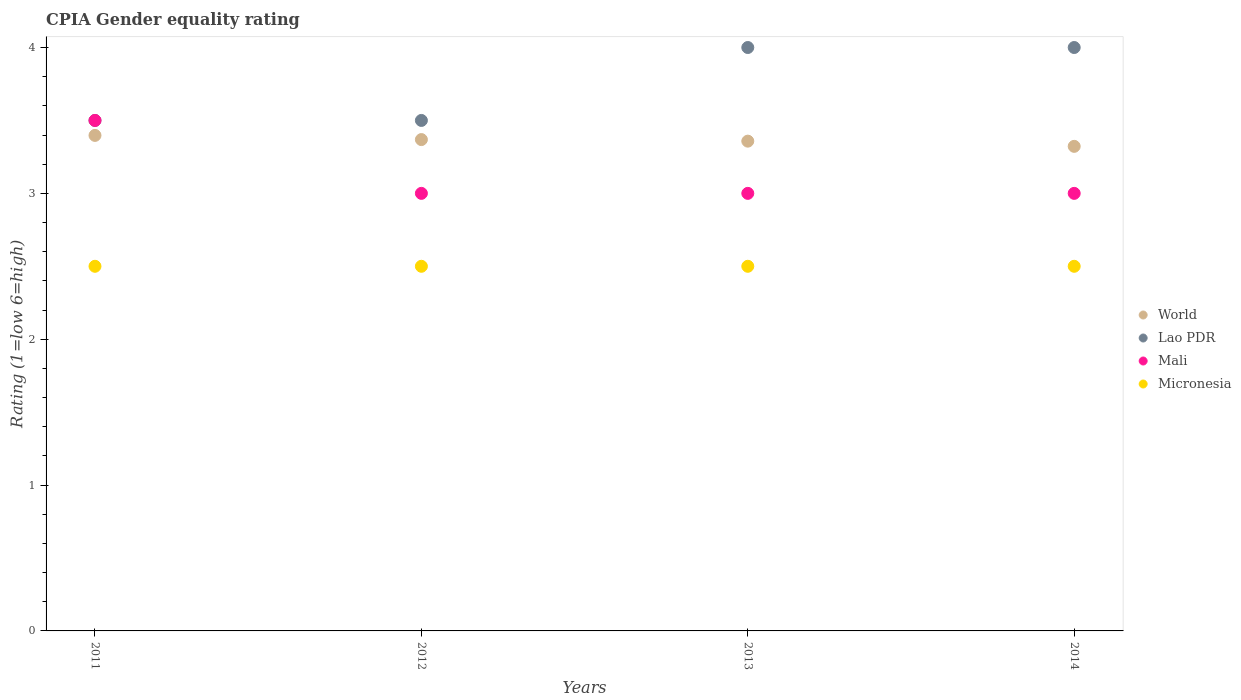How many different coloured dotlines are there?
Your answer should be compact. 4. What is the CPIA rating in World in 2011?
Your answer should be compact. 3.4. Across all years, what is the maximum CPIA rating in Lao PDR?
Your response must be concise. 4. Across all years, what is the minimum CPIA rating in Micronesia?
Ensure brevity in your answer.  2.5. In which year was the CPIA rating in Micronesia maximum?
Your answer should be compact. 2011. What is the total CPIA rating in Lao PDR in the graph?
Your answer should be very brief. 15. What is the average CPIA rating in World per year?
Provide a short and direct response. 3.36. In how many years, is the CPIA rating in Mali greater than 1.6?
Keep it short and to the point. 4. Is the difference between the CPIA rating in Micronesia in 2011 and 2012 greater than the difference between the CPIA rating in Lao PDR in 2011 and 2012?
Provide a short and direct response. No. What is the difference between the highest and the second highest CPIA rating in World?
Ensure brevity in your answer.  0.03. What is the difference between the highest and the lowest CPIA rating in Mali?
Keep it short and to the point. 0.5. Is the sum of the CPIA rating in Mali in 2013 and 2014 greater than the maximum CPIA rating in Lao PDR across all years?
Your answer should be very brief. Yes. Is it the case that in every year, the sum of the CPIA rating in Lao PDR and CPIA rating in World  is greater than the sum of CPIA rating in Micronesia and CPIA rating in Mali?
Provide a succinct answer. No. How many dotlines are there?
Your response must be concise. 4. Does the graph contain any zero values?
Provide a short and direct response. No. Where does the legend appear in the graph?
Your response must be concise. Center right. How many legend labels are there?
Your response must be concise. 4. How are the legend labels stacked?
Keep it short and to the point. Vertical. What is the title of the graph?
Provide a short and direct response. CPIA Gender equality rating. Does "Andorra" appear as one of the legend labels in the graph?
Your answer should be very brief. No. What is the label or title of the X-axis?
Provide a short and direct response. Years. What is the label or title of the Y-axis?
Give a very brief answer. Rating (1=low 6=high). What is the Rating (1=low 6=high) of World in 2011?
Your answer should be very brief. 3.4. What is the Rating (1=low 6=high) of Mali in 2011?
Make the answer very short. 3.5. What is the Rating (1=low 6=high) in Micronesia in 2011?
Your response must be concise. 2.5. What is the Rating (1=low 6=high) in World in 2012?
Keep it short and to the point. 3.37. What is the Rating (1=low 6=high) in Mali in 2012?
Your answer should be very brief. 3. What is the Rating (1=low 6=high) of Micronesia in 2012?
Ensure brevity in your answer.  2.5. What is the Rating (1=low 6=high) of World in 2013?
Offer a terse response. 3.36. What is the Rating (1=low 6=high) of Mali in 2013?
Your answer should be compact. 3. What is the Rating (1=low 6=high) of World in 2014?
Ensure brevity in your answer.  3.32. What is the Rating (1=low 6=high) of Lao PDR in 2014?
Offer a very short reply. 4. Across all years, what is the maximum Rating (1=low 6=high) of World?
Your response must be concise. 3.4. Across all years, what is the maximum Rating (1=low 6=high) of Mali?
Provide a succinct answer. 3.5. Across all years, what is the maximum Rating (1=low 6=high) of Micronesia?
Make the answer very short. 2.5. Across all years, what is the minimum Rating (1=low 6=high) in World?
Provide a succinct answer. 3.32. Across all years, what is the minimum Rating (1=low 6=high) in Lao PDR?
Ensure brevity in your answer.  3.5. Across all years, what is the minimum Rating (1=low 6=high) of Mali?
Your response must be concise. 3. Across all years, what is the minimum Rating (1=low 6=high) in Micronesia?
Your answer should be very brief. 2.5. What is the total Rating (1=low 6=high) of World in the graph?
Give a very brief answer. 13.45. What is the difference between the Rating (1=low 6=high) in World in 2011 and that in 2012?
Provide a succinct answer. 0.03. What is the difference between the Rating (1=low 6=high) of Lao PDR in 2011 and that in 2012?
Provide a short and direct response. 0. What is the difference between the Rating (1=low 6=high) of Mali in 2011 and that in 2012?
Make the answer very short. 0.5. What is the difference between the Rating (1=low 6=high) of Micronesia in 2011 and that in 2012?
Your answer should be very brief. 0. What is the difference between the Rating (1=low 6=high) in World in 2011 and that in 2013?
Keep it short and to the point. 0.04. What is the difference between the Rating (1=low 6=high) in Mali in 2011 and that in 2013?
Provide a short and direct response. 0.5. What is the difference between the Rating (1=low 6=high) in Micronesia in 2011 and that in 2013?
Provide a succinct answer. 0. What is the difference between the Rating (1=low 6=high) of World in 2011 and that in 2014?
Your response must be concise. 0.08. What is the difference between the Rating (1=low 6=high) of Mali in 2011 and that in 2014?
Offer a terse response. 0.5. What is the difference between the Rating (1=low 6=high) in World in 2012 and that in 2013?
Make the answer very short. 0.01. What is the difference between the Rating (1=low 6=high) of Lao PDR in 2012 and that in 2013?
Make the answer very short. -0.5. What is the difference between the Rating (1=low 6=high) in World in 2012 and that in 2014?
Offer a terse response. 0.05. What is the difference between the Rating (1=low 6=high) of Micronesia in 2012 and that in 2014?
Give a very brief answer. 0. What is the difference between the Rating (1=low 6=high) of World in 2013 and that in 2014?
Ensure brevity in your answer.  0.04. What is the difference between the Rating (1=low 6=high) in Lao PDR in 2013 and that in 2014?
Make the answer very short. 0. What is the difference between the Rating (1=low 6=high) of Micronesia in 2013 and that in 2014?
Make the answer very short. 0. What is the difference between the Rating (1=low 6=high) of World in 2011 and the Rating (1=low 6=high) of Lao PDR in 2012?
Keep it short and to the point. -0.1. What is the difference between the Rating (1=low 6=high) in World in 2011 and the Rating (1=low 6=high) in Mali in 2012?
Your answer should be compact. 0.4. What is the difference between the Rating (1=low 6=high) of World in 2011 and the Rating (1=low 6=high) of Micronesia in 2012?
Your answer should be very brief. 0.9. What is the difference between the Rating (1=low 6=high) in Lao PDR in 2011 and the Rating (1=low 6=high) in Mali in 2012?
Your answer should be very brief. 0.5. What is the difference between the Rating (1=low 6=high) in Lao PDR in 2011 and the Rating (1=low 6=high) in Micronesia in 2012?
Your answer should be very brief. 1. What is the difference between the Rating (1=low 6=high) of World in 2011 and the Rating (1=low 6=high) of Lao PDR in 2013?
Make the answer very short. -0.6. What is the difference between the Rating (1=low 6=high) in World in 2011 and the Rating (1=low 6=high) in Mali in 2013?
Offer a very short reply. 0.4. What is the difference between the Rating (1=low 6=high) in World in 2011 and the Rating (1=low 6=high) in Micronesia in 2013?
Your answer should be compact. 0.9. What is the difference between the Rating (1=low 6=high) in World in 2011 and the Rating (1=low 6=high) in Lao PDR in 2014?
Your response must be concise. -0.6. What is the difference between the Rating (1=low 6=high) in World in 2011 and the Rating (1=low 6=high) in Mali in 2014?
Ensure brevity in your answer.  0.4. What is the difference between the Rating (1=low 6=high) in World in 2011 and the Rating (1=low 6=high) in Micronesia in 2014?
Your answer should be very brief. 0.9. What is the difference between the Rating (1=low 6=high) in World in 2012 and the Rating (1=low 6=high) in Lao PDR in 2013?
Provide a short and direct response. -0.63. What is the difference between the Rating (1=low 6=high) of World in 2012 and the Rating (1=low 6=high) of Mali in 2013?
Offer a very short reply. 0.37. What is the difference between the Rating (1=low 6=high) of World in 2012 and the Rating (1=low 6=high) of Micronesia in 2013?
Your answer should be very brief. 0.87. What is the difference between the Rating (1=low 6=high) of Lao PDR in 2012 and the Rating (1=low 6=high) of Micronesia in 2013?
Ensure brevity in your answer.  1. What is the difference between the Rating (1=low 6=high) in World in 2012 and the Rating (1=low 6=high) in Lao PDR in 2014?
Your response must be concise. -0.63. What is the difference between the Rating (1=low 6=high) in World in 2012 and the Rating (1=low 6=high) in Mali in 2014?
Your answer should be very brief. 0.37. What is the difference between the Rating (1=low 6=high) of World in 2012 and the Rating (1=low 6=high) of Micronesia in 2014?
Provide a succinct answer. 0.87. What is the difference between the Rating (1=low 6=high) of Mali in 2012 and the Rating (1=low 6=high) of Micronesia in 2014?
Your answer should be very brief. 0.5. What is the difference between the Rating (1=low 6=high) of World in 2013 and the Rating (1=low 6=high) of Lao PDR in 2014?
Your response must be concise. -0.64. What is the difference between the Rating (1=low 6=high) in World in 2013 and the Rating (1=low 6=high) in Mali in 2014?
Give a very brief answer. 0.36. What is the difference between the Rating (1=low 6=high) in World in 2013 and the Rating (1=low 6=high) in Micronesia in 2014?
Offer a terse response. 0.86. What is the difference between the Rating (1=low 6=high) in Mali in 2013 and the Rating (1=low 6=high) in Micronesia in 2014?
Offer a terse response. 0.5. What is the average Rating (1=low 6=high) of World per year?
Your answer should be compact. 3.36. What is the average Rating (1=low 6=high) in Lao PDR per year?
Give a very brief answer. 3.75. What is the average Rating (1=low 6=high) in Mali per year?
Your response must be concise. 3.12. What is the average Rating (1=low 6=high) of Micronesia per year?
Ensure brevity in your answer.  2.5. In the year 2011, what is the difference between the Rating (1=low 6=high) of World and Rating (1=low 6=high) of Lao PDR?
Your answer should be compact. -0.1. In the year 2011, what is the difference between the Rating (1=low 6=high) in World and Rating (1=low 6=high) in Mali?
Provide a succinct answer. -0.1. In the year 2011, what is the difference between the Rating (1=low 6=high) of World and Rating (1=low 6=high) of Micronesia?
Your answer should be compact. 0.9. In the year 2011, what is the difference between the Rating (1=low 6=high) of Lao PDR and Rating (1=low 6=high) of Mali?
Your answer should be very brief. 0. In the year 2011, what is the difference between the Rating (1=low 6=high) in Lao PDR and Rating (1=low 6=high) in Micronesia?
Offer a very short reply. 1. In the year 2012, what is the difference between the Rating (1=low 6=high) in World and Rating (1=low 6=high) in Lao PDR?
Your response must be concise. -0.13. In the year 2012, what is the difference between the Rating (1=low 6=high) in World and Rating (1=low 6=high) in Mali?
Your answer should be compact. 0.37. In the year 2012, what is the difference between the Rating (1=low 6=high) of World and Rating (1=low 6=high) of Micronesia?
Your answer should be very brief. 0.87. In the year 2012, what is the difference between the Rating (1=low 6=high) of Lao PDR and Rating (1=low 6=high) of Mali?
Ensure brevity in your answer.  0.5. In the year 2012, what is the difference between the Rating (1=low 6=high) in Mali and Rating (1=low 6=high) in Micronesia?
Your answer should be compact. 0.5. In the year 2013, what is the difference between the Rating (1=low 6=high) in World and Rating (1=low 6=high) in Lao PDR?
Offer a very short reply. -0.64. In the year 2013, what is the difference between the Rating (1=low 6=high) of World and Rating (1=low 6=high) of Mali?
Provide a short and direct response. 0.36. In the year 2013, what is the difference between the Rating (1=low 6=high) in World and Rating (1=low 6=high) in Micronesia?
Your answer should be compact. 0.86. In the year 2013, what is the difference between the Rating (1=low 6=high) in Lao PDR and Rating (1=low 6=high) in Micronesia?
Give a very brief answer. 1.5. In the year 2014, what is the difference between the Rating (1=low 6=high) of World and Rating (1=low 6=high) of Lao PDR?
Your answer should be very brief. -0.68. In the year 2014, what is the difference between the Rating (1=low 6=high) of World and Rating (1=low 6=high) of Mali?
Your answer should be very brief. 0.32. In the year 2014, what is the difference between the Rating (1=low 6=high) in World and Rating (1=low 6=high) in Micronesia?
Give a very brief answer. 0.82. In the year 2014, what is the difference between the Rating (1=low 6=high) in Lao PDR and Rating (1=low 6=high) in Mali?
Offer a very short reply. 1. In the year 2014, what is the difference between the Rating (1=low 6=high) in Lao PDR and Rating (1=low 6=high) in Micronesia?
Your response must be concise. 1.5. What is the ratio of the Rating (1=low 6=high) in World in 2011 to that in 2012?
Your answer should be very brief. 1.01. What is the ratio of the Rating (1=low 6=high) in Mali in 2011 to that in 2012?
Keep it short and to the point. 1.17. What is the ratio of the Rating (1=low 6=high) in Micronesia in 2011 to that in 2012?
Make the answer very short. 1. What is the ratio of the Rating (1=low 6=high) of World in 2011 to that in 2013?
Your answer should be compact. 1.01. What is the ratio of the Rating (1=low 6=high) in Lao PDR in 2011 to that in 2013?
Ensure brevity in your answer.  0.88. What is the ratio of the Rating (1=low 6=high) of Mali in 2011 to that in 2013?
Make the answer very short. 1.17. What is the ratio of the Rating (1=low 6=high) of Micronesia in 2011 to that in 2013?
Offer a very short reply. 1. What is the ratio of the Rating (1=low 6=high) in World in 2011 to that in 2014?
Ensure brevity in your answer.  1.02. What is the ratio of the Rating (1=low 6=high) in Lao PDR in 2011 to that in 2014?
Your response must be concise. 0.88. What is the ratio of the Rating (1=low 6=high) of Lao PDR in 2012 to that in 2013?
Provide a short and direct response. 0.88. What is the ratio of the Rating (1=low 6=high) of Micronesia in 2012 to that in 2013?
Offer a very short reply. 1. What is the ratio of the Rating (1=low 6=high) in Lao PDR in 2012 to that in 2014?
Your answer should be very brief. 0.88. What is the ratio of the Rating (1=low 6=high) of Micronesia in 2012 to that in 2014?
Keep it short and to the point. 1. What is the ratio of the Rating (1=low 6=high) of World in 2013 to that in 2014?
Your answer should be compact. 1.01. What is the ratio of the Rating (1=low 6=high) in Mali in 2013 to that in 2014?
Give a very brief answer. 1. What is the ratio of the Rating (1=low 6=high) in Micronesia in 2013 to that in 2014?
Your answer should be compact. 1. What is the difference between the highest and the second highest Rating (1=low 6=high) of World?
Keep it short and to the point. 0.03. What is the difference between the highest and the second highest Rating (1=low 6=high) of Mali?
Your response must be concise. 0.5. What is the difference between the highest and the second highest Rating (1=low 6=high) in Micronesia?
Ensure brevity in your answer.  0. What is the difference between the highest and the lowest Rating (1=low 6=high) in World?
Your response must be concise. 0.08. What is the difference between the highest and the lowest Rating (1=low 6=high) of Lao PDR?
Offer a terse response. 0.5. What is the difference between the highest and the lowest Rating (1=low 6=high) of Mali?
Make the answer very short. 0.5. What is the difference between the highest and the lowest Rating (1=low 6=high) of Micronesia?
Your answer should be compact. 0. 